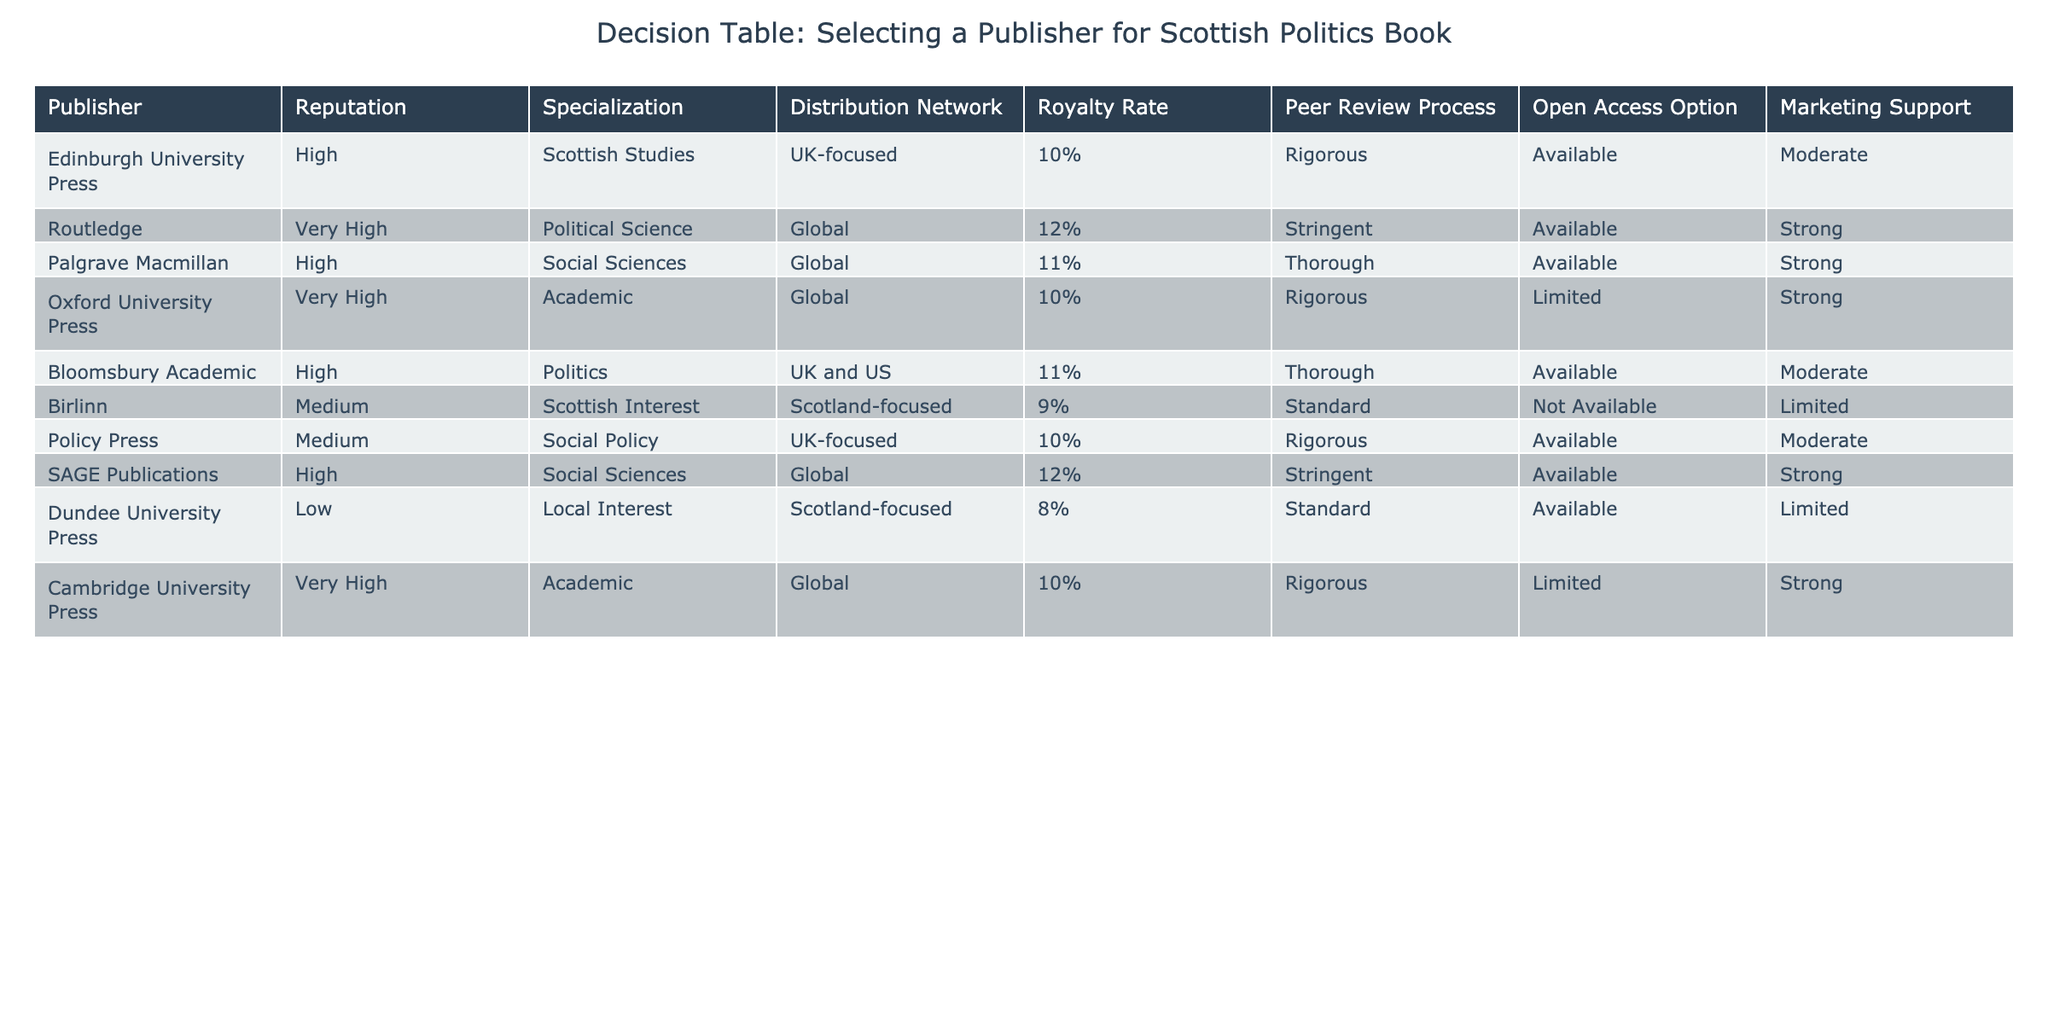What is the reputation of Routledge? The table shows that Routledge has a reputation labeled as "Very High."
Answer: Very High Which publisher offers the highest royalty rate? By examining the Royalty Rate column, both SAGE Publications and Routledge offer a royalty rate of 12%, which is the highest among all publishers.
Answer: 12% How many publishers provide an Open Access option? The table lists the publishers that provide an Open Access option, and counting them reveals that there are 6 with this option available (Edinburgh University Press, Routledge, Palgrave Macmillan, SAGE Publications, and Bloomsbury Academic) out of the total 10 publishers.
Answer: 6 Is there any publisher that specializes specifically in Scottish Interest? From the table, we can see that Birlinn is listed as specializing in Scottish Interest, which confirms that such a publisher exists.
Answer: Yes What is the average royalty rate of publishers that have a "High" reputation? The publishers with a "High" reputation along with their royalty rates are Edinburgh University Press (10%), Palgrave Macmillan (11%), Bloomsbury Academic (11%), and SAGE Publications (12%). Summing these rates gives 10 + 11 + 11 + 12 = 44. There are 4 publishers, so the average is 44/4 = 11.
Answer: 11 Which publisher has both a High reputation and a Thorough peer review process? By filtering through the table, we find Palgrave Macmillan and Bloomsbury Academic both meet the criteria of having a High reputation and a Thorough peer review process.
Answer: Palgrave Macmillan, Bloomsbury Academic How many publishers have a global distribution network and also offer a rigorous peer review process? The relevant publishers that fit this criteria from the table include Routledge, Oxford University Press, SAGE Publications, and Cambridge University Press. Counting these gives us a total of 4 publishers.
Answer: 4 Is it true that Dundee University Press has a moderate level of marketing support? Checking the table reveals that Dundee University Press has a "Limited" level of marketing support, making the statement false.
Answer: No What is the difference in royalty rates between publishers with Very High reputation and those with Low reputation? From the table, the royalty rates for Very High reputation publishers (Routledge, Oxford University Press, Cambridge University Press) average to 10% (as per the provided values). Dundee University Press, as the only publisher with Low reputation, has a rate of 8%. Therefore, the difference is 10% - 8% = 2%.
Answer: 2% 